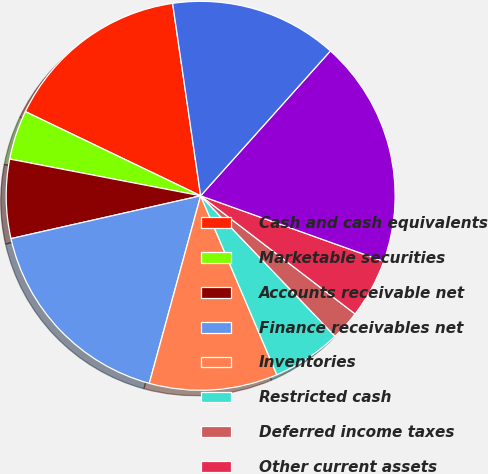Convert chart to OTSL. <chart><loc_0><loc_0><loc_500><loc_500><pie_chart><fcel>Cash and cash equivalents<fcel>Marketable securities<fcel>Accounts receivable net<fcel>Finance receivables net<fcel>Inventories<fcel>Restricted cash<fcel>Deferred income taxes<fcel>Other current assets<fcel>Total current assets<fcel>Property plant and equipment<nl><fcel>15.57%<fcel>4.1%<fcel>6.56%<fcel>17.21%<fcel>10.66%<fcel>5.74%<fcel>2.46%<fcel>4.92%<fcel>18.85%<fcel>13.93%<nl></chart> 